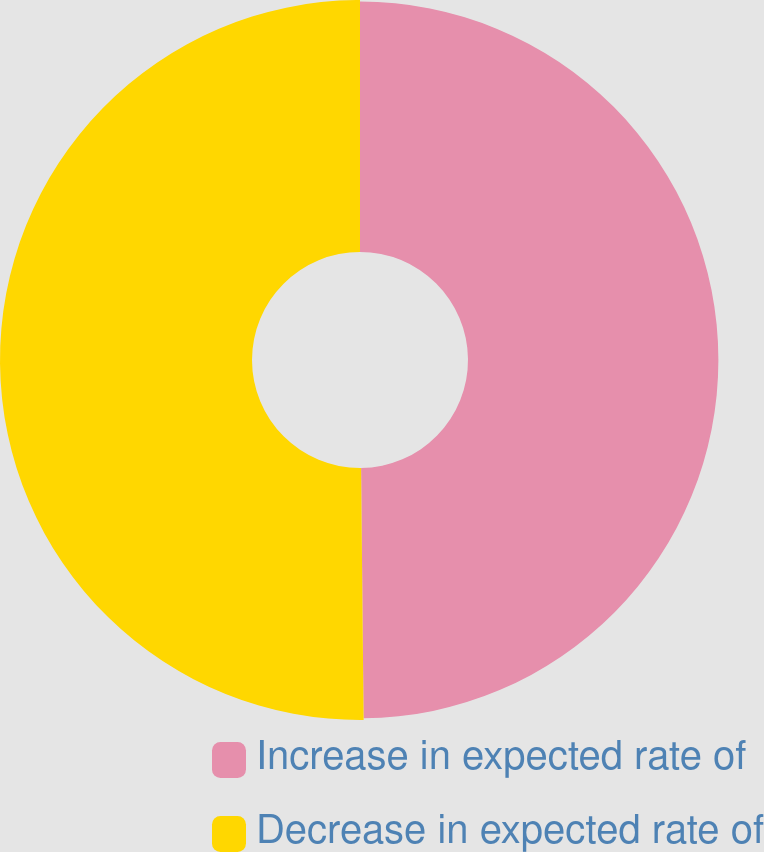Convert chart to OTSL. <chart><loc_0><loc_0><loc_500><loc_500><pie_chart><fcel>Increase in expected rate of<fcel>Decrease in expected rate of<nl><fcel>49.84%<fcel>50.16%<nl></chart> 